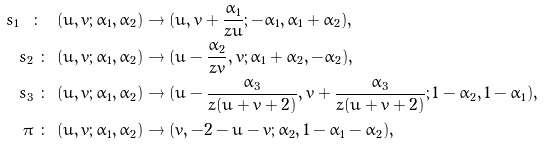<formula> <loc_0><loc_0><loc_500><loc_500>s _ { 1 } \ \colon \ & ( u , v ; \alpha _ { 1 } , \alpha _ { 2 } ) \to ( u , v + \frac { \alpha _ { 1 } } { z u } ; - \alpha _ { 1 } , \alpha _ { 1 } + \alpha _ { 2 } ) , \\ s _ { 2 } \ \colon \ & ( u , v ; \alpha _ { 1 } , \alpha _ { 2 } ) \to ( u - \frac { \alpha _ { 2 } } { z v } , v ; \alpha _ { 1 } + \alpha _ { 2 } , - \alpha _ { 2 } ) , \\ s _ { 3 } \ \colon \ & ( u , v ; \alpha _ { 1 } , \alpha _ { 2 } ) \to ( u - \frac { \alpha _ { 3 } } { z ( u + v + 2 ) } , v + \frac { \alpha _ { 3 } } { z ( u + v + 2 ) } ; 1 - \alpha _ { 2 } , 1 - \alpha _ { 1 } ) , \\ \pi \ \colon \ & ( u , v ; \alpha _ { 1 } , \alpha _ { 2 } ) \to ( v , - 2 - u - v ; \alpha _ { 2 } , 1 - \alpha _ { 1 } - \alpha _ { 2 } ) ,</formula> 